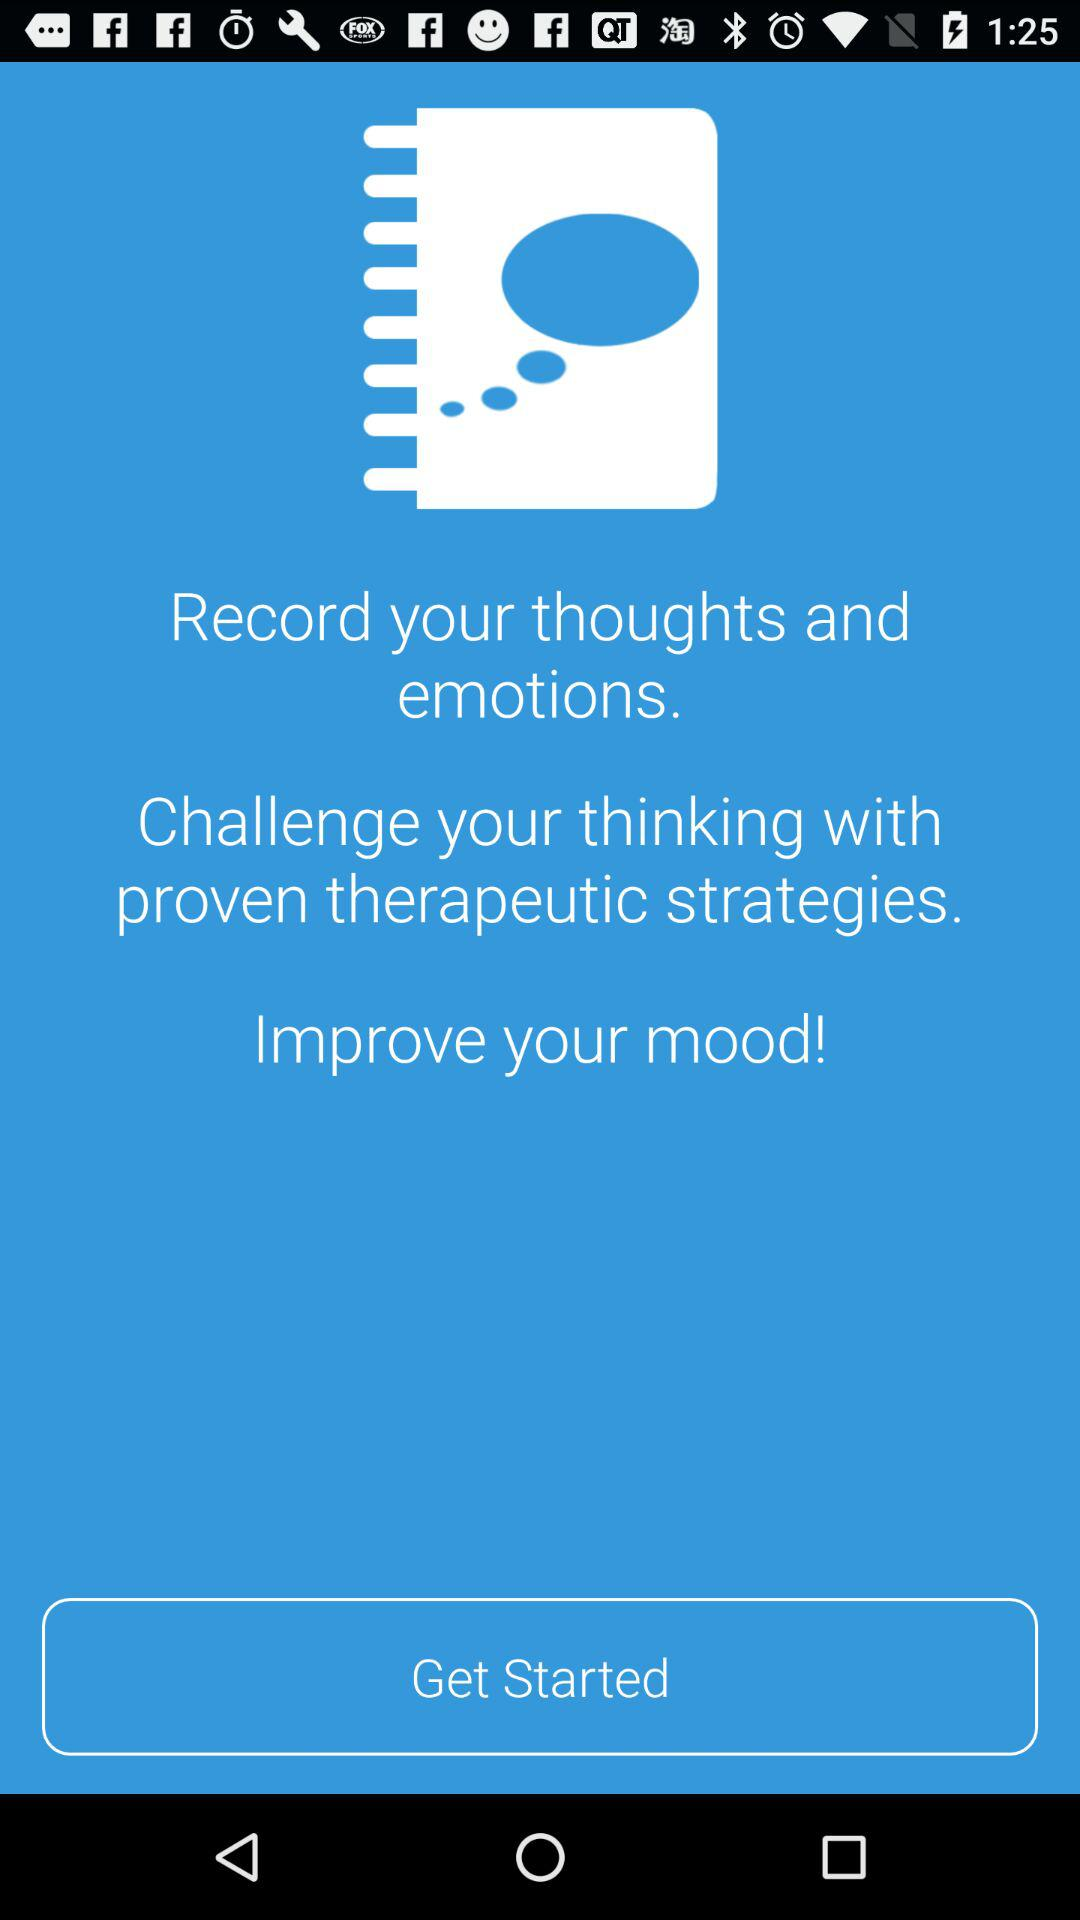What are the strategies to challenge the thinking? There are proven therapeutic strategies to challenge the thinking. 